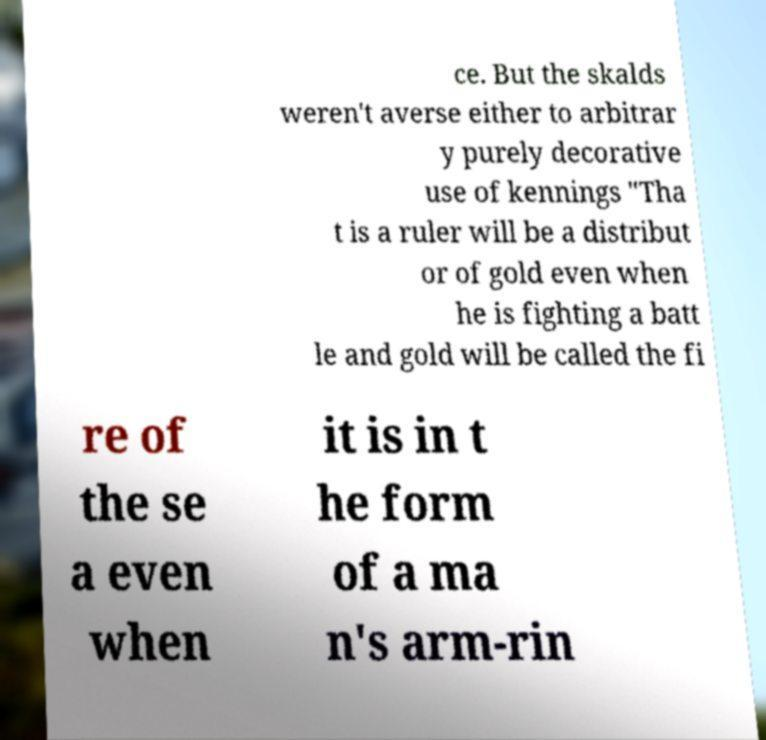Please identify and transcribe the text found in this image. ce. But the skalds weren't averse either to arbitrar y purely decorative use of kennings "Tha t is a ruler will be a distribut or of gold even when he is fighting a batt le and gold will be called the fi re of the se a even when it is in t he form of a ma n's arm-rin 